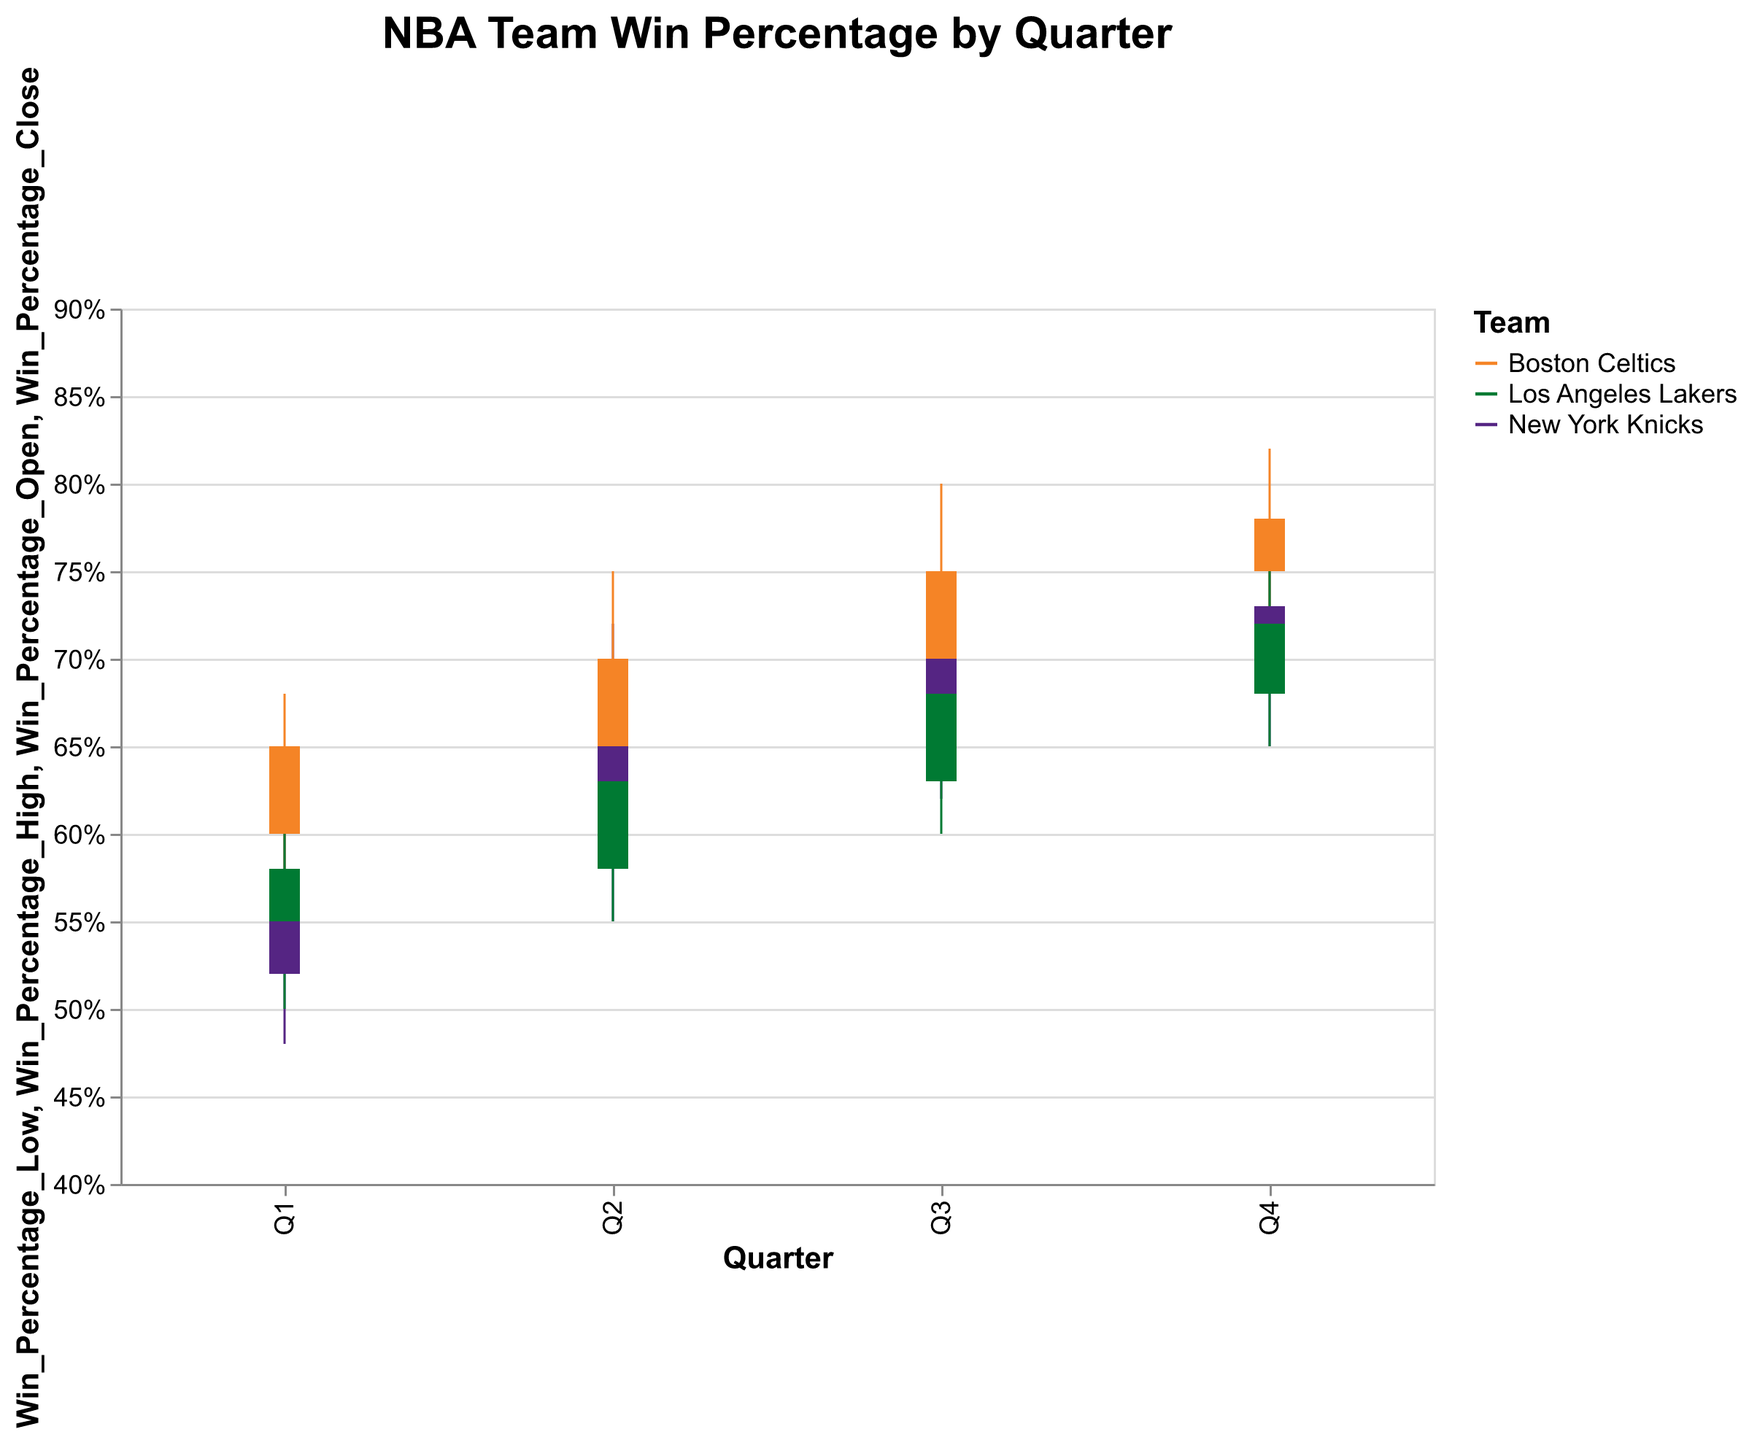What's the title of the chart? The title of the chart is displayed at the top center, indicating the overall subject of the visualized data. From the data, the title reads "NBA Team Win Percentage by Quarter".
Answer: NBA Team Win Percentage by Quarter Which team has the highest win percentage close in Q4? To find this, look for the close win percentage values (y2-axis) in quarter Q4 for all teams. Boston Celtics have the highest win percentage close at 0.78.
Answer: Boston Celtics What is the color used for the Los Angeles Lakers in the chart? The color for each team is specified in the chart legend. The Los Angeles Lakers are represented by a purple color.
Answer: Purple Which quarter shows the highest win percentage high for the New York Knicks? Check the win percentage high values for each quarter for the New York Knicks. Q4 has the highest win percentage high at 0.78.
Answer: Q4 Between Q1 and Q4, how much did the win percentage close change for the New York Knicks? Calculate the difference between the win percentage close in Q1 and Q4 for the New York Knicks. The percentages are 0.58 in Q1 and 0.73 in Q4. So, the change is 0.73 - 0.58 = 0.15.
Answer: 0.15 Which team has the lowest defensive rating in any quarter, and what is that value? Check the defensive rating values across all quarters and teams and find the lowest. The Boston Celtics in Q4 have the lowest defensive rating at 106.5.
Answer: Boston Celtics, 106.5 On average, by how much did the Boston Celtics' win percentage close increase each quarter? Calculate the changes in win percentage close for the Boston Celtics from Q1 to Q2, Q2 to Q3, and Q3 to Q4. The values are 0.65 to 0.70 (+0.05), 0.70 to 0.75 (+0.05), 0.75 to 0.78 (+0.03). Average increase is (0.05 + 0.05 + 0.03) / 3 = 0.0433.
Answer: 0.0433 Which team improved its defensive rating the most from Q1 to Q4? Compare the defensive rating changes of all teams from Q1 to Q4. The New York Knicks improved from 110.2 to 106.9, which is the maximum reduction of 3.3 points.
Answer: New York Knicks What's the difference in points scored between the Boston Celtics and Los Angeles Lakers in Q3? Subtract the points scored by the Los Angeles Lakers from those scored by the Boston Celtics in Q3. Boston Celtics scored 2950, and Los Angeles Lakers scored 2925. The difference is 2950 - 2925 = 25.
Answer: 25 In which quarter did the Los Angeles Lakers have the smallest win percentage range, and what is that range? Calculate the win percentage range (High - Low) for all quarters for the Los Angeles Lakers. The smallest range is in Q3 (0.72 - 0.60 = 0.12).
Answer: Q3, 0.12 